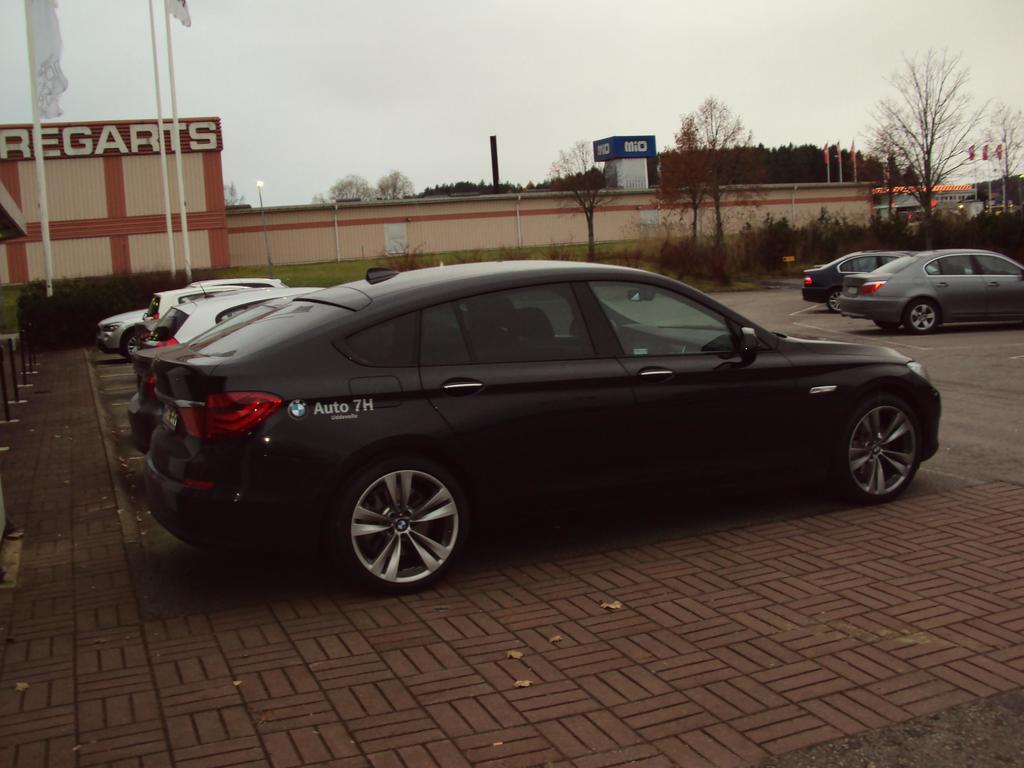In one or two sentences, can you explain what this image depicts? There are cars in the middle of this image. We can see a wall and trees in the background. The sky is at the top of this image. 